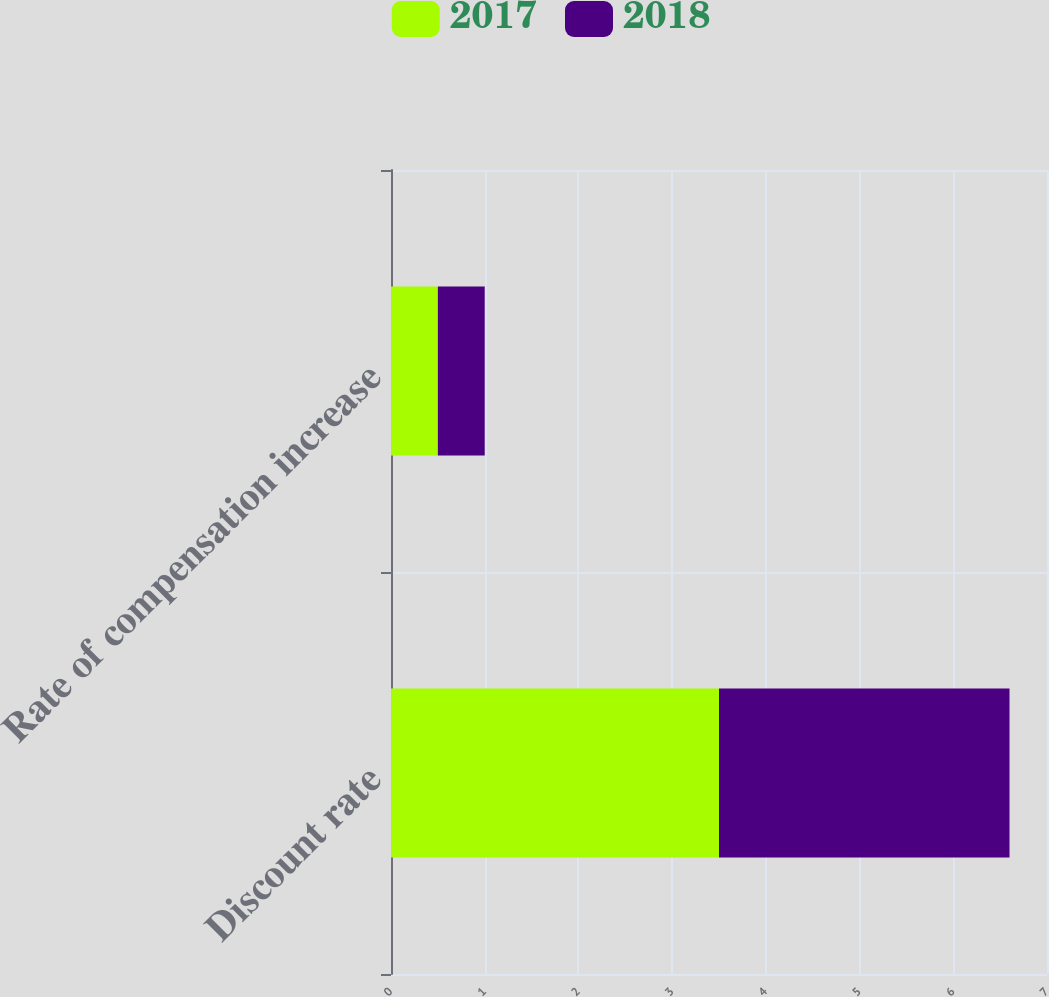Convert chart to OTSL. <chart><loc_0><loc_0><loc_500><loc_500><stacked_bar_chart><ecel><fcel>Discount rate<fcel>Rate of compensation increase<nl><fcel>2017<fcel>3.5<fcel>0.5<nl><fcel>2018<fcel>3.1<fcel>0.5<nl></chart> 